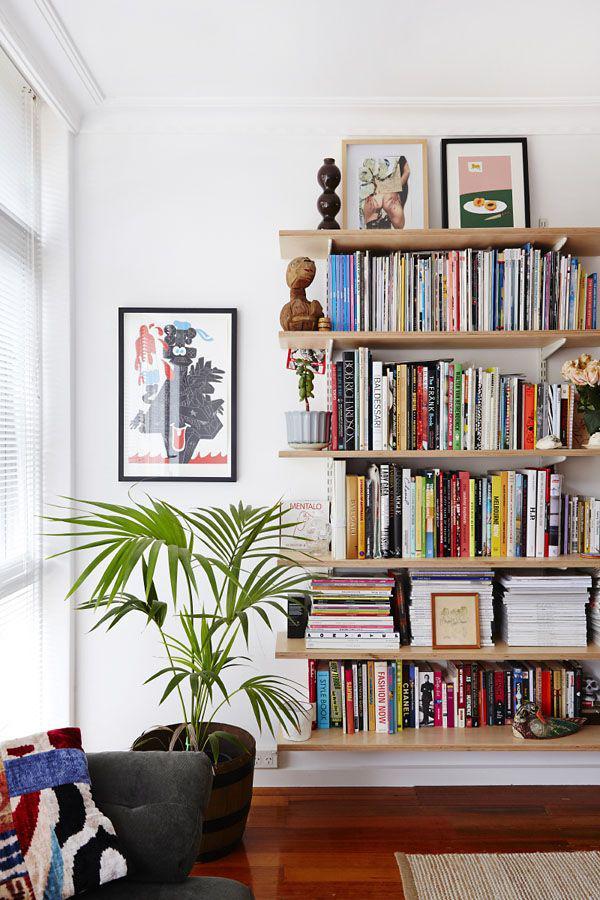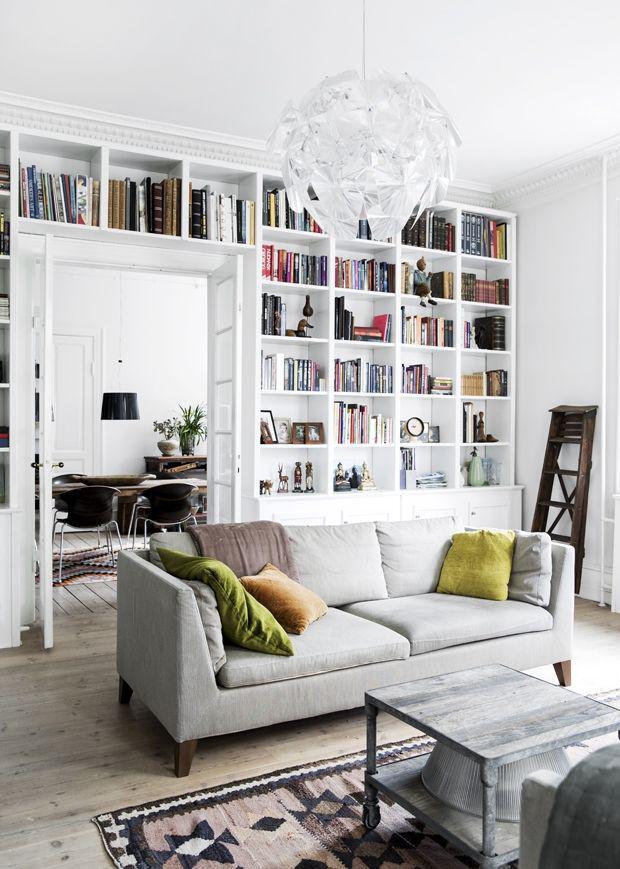The first image is the image on the left, the second image is the image on the right. Given the left and right images, does the statement "A ceiling lamp that hangs over a room is glass-like." hold true? Answer yes or no. Yes. The first image is the image on the left, the second image is the image on the right. For the images displayed, is the sentence "A green plant with fanning leaves is near a backless and sideless set of vertical shelves." factually correct? Answer yes or no. Yes. 